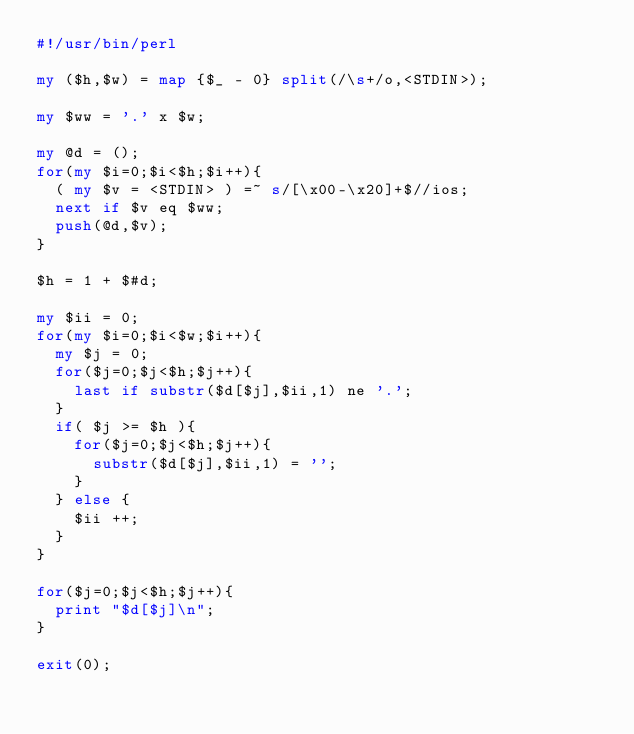Convert code to text. <code><loc_0><loc_0><loc_500><loc_500><_Perl_>#!/usr/bin/perl

my ($h,$w) = map {$_ - 0} split(/\s+/o,<STDIN>);

my $ww = '.' x $w;

my @d = ();
for(my $i=0;$i<$h;$i++){
  ( my $v = <STDIN> ) =~ s/[\x00-\x20]+$//ios;
  next if $v eq $ww;
  push(@d,$v);
}

$h = 1 + $#d;

my $ii = 0;
for(my $i=0;$i<$w;$i++){
  my $j = 0;
  for($j=0;$j<$h;$j++){
    last if substr($d[$j],$ii,1) ne '.';
  }
  if( $j >= $h ){
    for($j=0;$j<$h;$j++){
      substr($d[$j],$ii,1) = '';
    }
  } else {
    $ii ++;
  }
}

for($j=0;$j<$h;$j++){
  print "$d[$j]\n";
}

exit(0);

</code> 